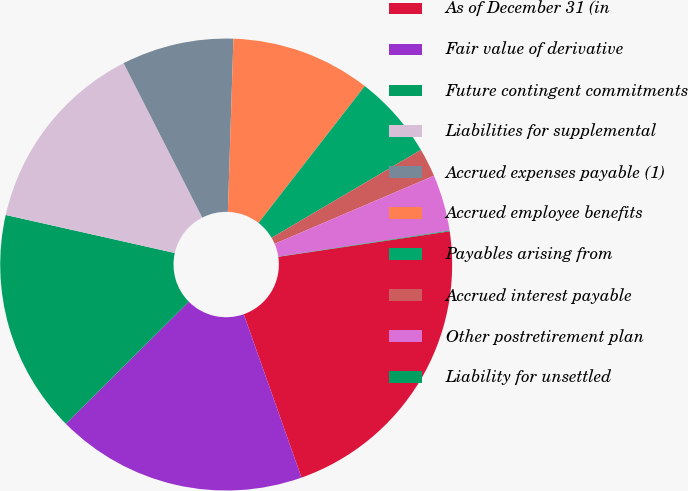<chart> <loc_0><loc_0><loc_500><loc_500><pie_chart><fcel>As of December 31 (in<fcel>Fair value of derivative<fcel>Future contingent commitments<fcel>Liabilities for supplemental<fcel>Accrued expenses payable (1)<fcel>Accrued employee benefits<fcel>Payables arising from<fcel>Accrued interest payable<fcel>Other postretirement plan<fcel>Liability for unsettled<nl><fcel>21.94%<fcel>17.96%<fcel>15.97%<fcel>13.98%<fcel>8.01%<fcel>10.0%<fcel>6.02%<fcel>2.04%<fcel>4.03%<fcel>0.05%<nl></chart> 